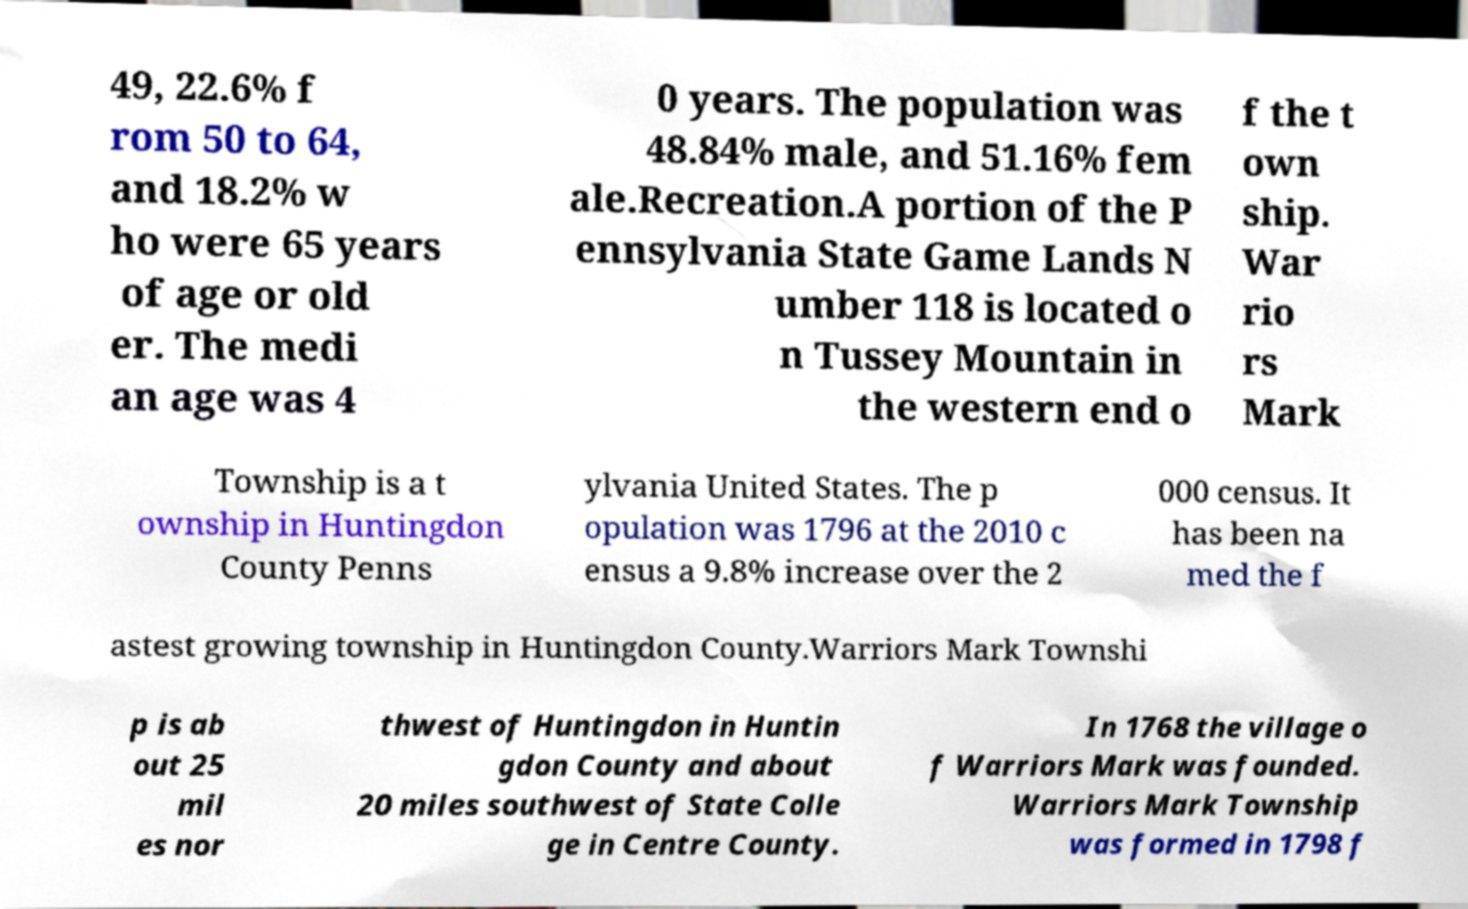For documentation purposes, I need the text within this image transcribed. Could you provide that? 49, 22.6% f rom 50 to 64, and 18.2% w ho were 65 years of age or old er. The medi an age was 4 0 years. The population was 48.84% male, and 51.16% fem ale.Recreation.A portion of the P ennsylvania State Game Lands N umber 118 is located o n Tussey Mountain in the western end o f the t own ship. War rio rs Mark Township is a t ownship in Huntingdon County Penns ylvania United States. The p opulation was 1796 at the 2010 c ensus a 9.8% increase over the 2 000 census. It has been na med the f astest growing township in Huntingdon County.Warriors Mark Townshi p is ab out 25 mil es nor thwest of Huntingdon in Huntin gdon County and about 20 miles southwest of State Colle ge in Centre County. In 1768 the village o f Warriors Mark was founded. Warriors Mark Township was formed in 1798 f 